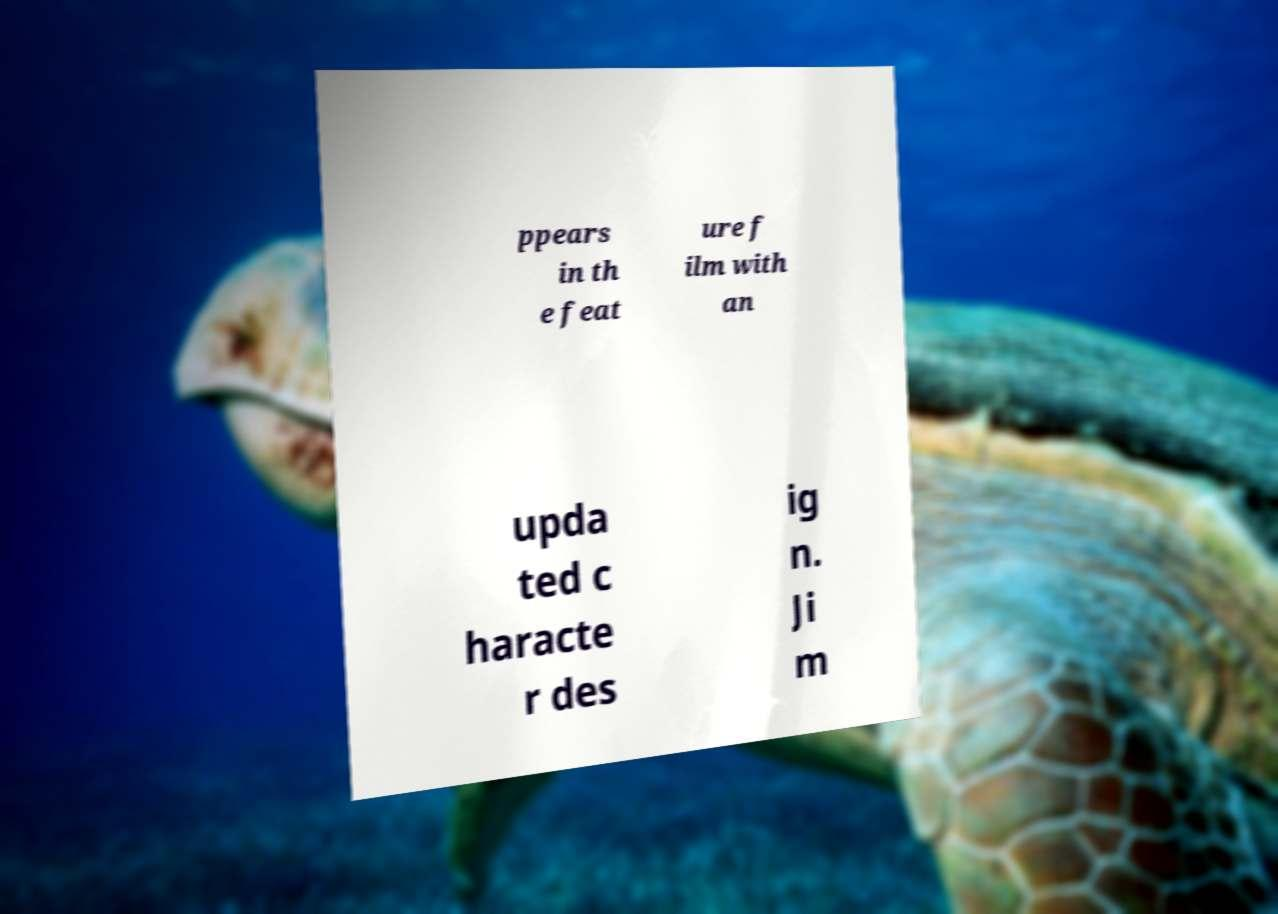Please read and relay the text visible in this image. What does it say? ppears in th e feat ure f ilm with an upda ted c haracte r des ig n. Ji m 